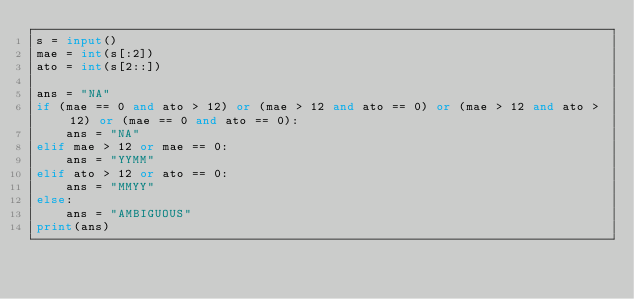<code> <loc_0><loc_0><loc_500><loc_500><_Python_>s = input()
mae = int(s[:2])
ato = int(s[2::])

ans = "NA"
if (mae == 0 and ato > 12) or (mae > 12 and ato == 0) or (mae > 12 and ato > 12) or (mae == 0 and ato == 0):
    ans = "NA"
elif mae > 12 or mae == 0:
    ans = "YYMM"
elif ato > 12 or ato == 0:
    ans = "MMYY"
else:
    ans = "AMBIGUOUS"
print(ans)

</code> 